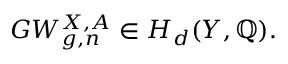Convert formula to latex. <formula><loc_0><loc_0><loc_500><loc_500>G W _ { g , n } ^ { X , A } \in H _ { d } ( Y , \mathbb { Q } ) .</formula> 